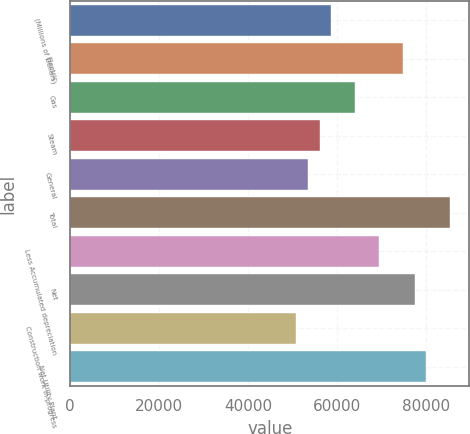Convert chart. <chart><loc_0><loc_0><loc_500><loc_500><bar_chart><fcel>(Millions of Dollars)<fcel>Electric<fcel>Gas<fcel>Steam<fcel>General<fcel>Total<fcel>Less Accumulated depreciation<fcel>Net<fcel>Construction work in progress<fcel>Net Utility Plant<nl><fcel>58716.2<fcel>74724.8<fcel>64052.4<fcel>56048.1<fcel>53380<fcel>85397.2<fcel>69388.6<fcel>77392.9<fcel>50711.9<fcel>80061<nl></chart> 